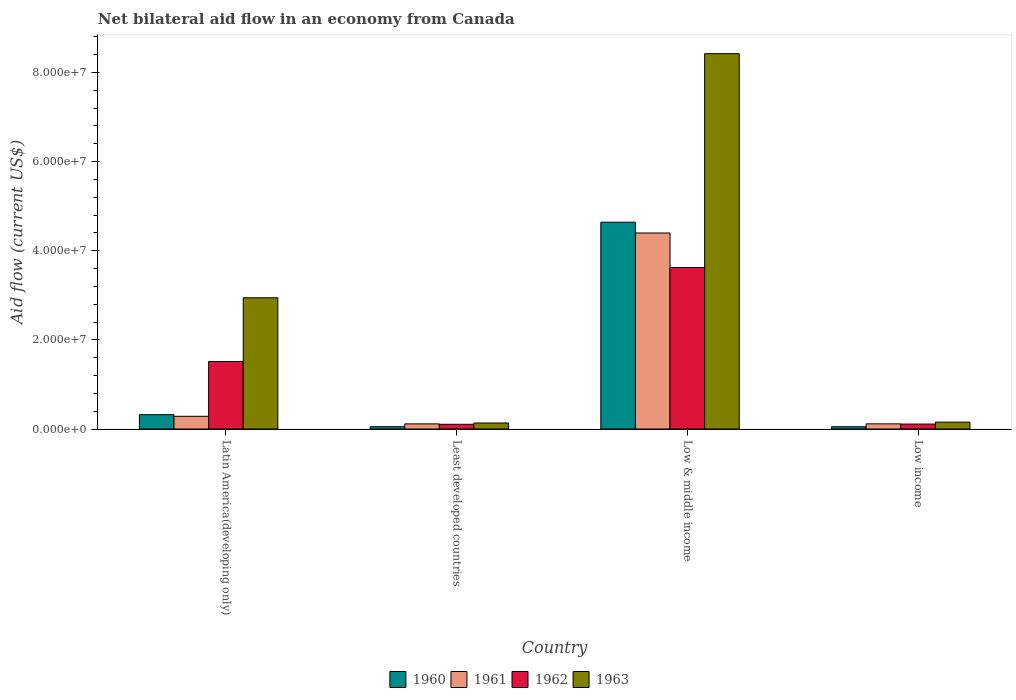How many different coloured bars are there?
Your answer should be very brief. 4. How many groups of bars are there?
Offer a very short reply. 4. Are the number of bars per tick equal to the number of legend labels?
Keep it short and to the point. Yes. How many bars are there on the 1st tick from the left?
Ensure brevity in your answer.  4. What is the label of the 2nd group of bars from the left?
Offer a terse response. Least developed countries. In how many cases, is the number of bars for a given country not equal to the number of legend labels?
Make the answer very short. 0. What is the net bilateral aid flow in 1960 in Least developed countries?
Ensure brevity in your answer.  5.20e+05. Across all countries, what is the maximum net bilateral aid flow in 1963?
Keep it short and to the point. 8.42e+07. Across all countries, what is the minimum net bilateral aid flow in 1963?
Your answer should be compact. 1.35e+06. In which country was the net bilateral aid flow in 1960 maximum?
Make the answer very short. Low & middle income. In which country was the net bilateral aid flow in 1963 minimum?
Your response must be concise. Least developed countries. What is the total net bilateral aid flow in 1960 in the graph?
Make the answer very short. 5.06e+07. What is the difference between the net bilateral aid flow in 1960 in Latin America(developing only) and that in Low & middle income?
Your answer should be very brief. -4.32e+07. What is the difference between the net bilateral aid flow in 1962 in Low income and the net bilateral aid flow in 1961 in Low & middle income?
Your answer should be compact. -4.29e+07. What is the average net bilateral aid flow in 1962 per country?
Provide a succinct answer. 1.34e+07. What is the ratio of the net bilateral aid flow in 1961 in Low & middle income to that in Low income?
Offer a terse response. 37.91. Is the difference between the net bilateral aid flow in 1961 in Latin America(developing only) and Low & middle income greater than the difference between the net bilateral aid flow in 1963 in Latin America(developing only) and Low & middle income?
Offer a terse response. Yes. What is the difference between the highest and the second highest net bilateral aid flow in 1960?
Your response must be concise. 4.32e+07. What is the difference between the highest and the lowest net bilateral aid flow in 1961?
Ensure brevity in your answer.  4.28e+07. In how many countries, is the net bilateral aid flow in 1960 greater than the average net bilateral aid flow in 1960 taken over all countries?
Your answer should be compact. 1. Is the sum of the net bilateral aid flow in 1963 in Least developed countries and Low income greater than the maximum net bilateral aid flow in 1962 across all countries?
Ensure brevity in your answer.  No. What does the 4th bar from the right in Latin America(developing only) represents?
Offer a terse response. 1960. What is the difference between two consecutive major ticks on the Y-axis?
Keep it short and to the point. 2.00e+07. Are the values on the major ticks of Y-axis written in scientific E-notation?
Give a very brief answer. Yes. Does the graph contain any zero values?
Ensure brevity in your answer.  No. Where does the legend appear in the graph?
Keep it short and to the point. Bottom center. How are the legend labels stacked?
Your response must be concise. Horizontal. What is the title of the graph?
Provide a succinct answer. Net bilateral aid flow in an economy from Canada. What is the label or title of the X-axis?
Keep it short and to the point. Country. What is the label or title of the Y-axis?
Your response must be concise. Aid flow (current US$). What is the Aid flow (current US$) of 1960 in Latin America(developing only)?
Offer a very short reply. 3.22e+06. What is the Aid flow (current US$) of 1961 in Latin America(developing only)?
Provide a short and direct response. 2.85e+06. What is the Aid flow (current US$) in 1962 in Latin America(developing only)?
Make the answer very short. 1.52e+07. What is the Aid flow (current US$) in 1963 in Latin America(developing only)?
Offer a very short reply. 2.94e+07. What is the Aid flow (current US$) of 1960 in Least developed countries?
Your answer should be very brief. 5.20e+05. What is the Aid flow (current US$) in 1961 in Least developed countries?
Ensure brevity in your answer.  1.15e+06. What is the Aid flow (current US$) of 1962 in Least developed countries?
Make the answer very short. 1.06e+06. What is the Aid flow (current US$) in 1963 in Least developed countries?
Give a very brief answer. 1.35e+06. What is the Aid flow (current US$) in 1960 in Low & middle income?
Your answer should be very brief. 4.64e+07. What is the Aid flow (current US$) in 1961 in Low & middle income?
Your response must be concise. 4.40e+07. What is the Aid flow (current US$) in 1962 in Low & middle income?
Provide a succinct answer. 3.62e+07. What is the Aid flow (current US$) in 1963 in Low & middle income?
Your answer should be compact. 8.42e+07. What is the Aid flow (current US$) of 1960 in Low income?
Ensure brevity in your answer.  5.10e+05. What is the Aid flow (current US$) in 1961 in Low income?
Keep it short and to the point. 1.16e+06. What is the Aid flow (current US$) in 1962 in Low income?
Keep it short and to the point. 1.11e+06. What is the Aid flow (current US$) in 1963 in Low income?
Ensure brevity in your answer.  1.54e+06. Across all countries, what is the maximum Aid flow (current US$) in 1960?
Give a very brief answer. 4.64e+07. Across all countries, what is the maximum Aid flow (current US$) in 1961?
Your answer should be compact. 4.40e+07. Across all countries, what is the maximum Aid flow (current US$) of 1962?
Offer a terse response. 3.62e+07. Across all countries, what is the maximum Aid flow (current US$) of 1963?
Offer a terse response. 8.42e+07. Across all countries, what is the minimum Aid flow (current US$) of 1960?
Keep it short and to the point. 5.10e+05. Across all countries, what is the minimum Aid flow (current US$) in 1961?
Provide a succinct answer. 1.15e+06. Across all countries, what is the minimum Aid flow (current US$) of 1962?
Keep it short and to the point. 1.06e+06. Across all countries, what is the minimum Aid flow (current US$) in 1963?
Your answer should be compact. 1.35e+06. What is the total Aid flow (current US$) of 1960 in the graph?
Provide a succinct answer. 5.06e+07. What is the total Aid flow (current US$) of 1961 in the graph?
Provide a short and direct response. 4.91e+07. What is the total Aid flow (current US$) of 1962 in the graph?
Offer a very short reply. 5.36e+07. What is the total Aid flow (current US$) of 1963 in the graph?
Provide a short and direct response. 1.17e+08. What is the difference between the Aid flow (current US$) in 1960 in Latin America(developing only) and that in Least developed countries?
Ensure brevity in your answer.  2.70e+06. What is the difference between the Aid flow (current US$) of 1961 in Latin America(developing only) and that in Least developed countries?
Give a very brief answer. 1.70e+06. What is the difference between the Aid flow (current US$) of 1962 in Latin America(developing only) and that in Least developed countries?
Provide a short and direct response. 1.41e+07. What is the difference between the Aid flow (current US$) in 1963 in Latin America(developing only) and that in Least developed countries?
Provide a short and direct response. 2.81e+07. What is the difference between the Aid flow (current US$) in 1960 in Latin America(developing only) and that in Low & middle income?
Make the answer very short. -4.32e+07. What is the difference between the Aid flow (current US$) of 1961 in Latin America(developing only) and that in Low & middle income?
Offer a very short reply. -4.11e+07. What is the difference between the Aid flow (current US$) of 1962 in Latin America(developing only) and that in Low & middle income?
Give a very brief answer. -2.11e+07. What is the difference between the Aid flow (current US$) in 1963 in Latin America(developing only) and that in Low & middle income?
Provide a short and direct response. -5.48e+07. What is the difference between the Aid flow (current US$) of 1960 in Latin America(developing only) and that in Low income?
Make the answer very short. 2.71e+06. What is the difference between the Aid flow (current US$) in 1961 in Latin America(developing only) and that in Low income?
Give a very brief answer. 1.69e+06. What is the difference between the Aid flow (current US$) of 1962 in Latin America(developing only) and that in Low income?
Keep it short and to the point. 1.40e+07. What is the difference between the Aid flow (current US$) of 1963 in Latin America(developing only) and that in Low income?
Offer a terse response. 2.79e+07. What is the difference between the Aid flow (current US$) of 1960 in Least developed countries and that in Low & middle income?
Provide a succinct answer. -4.59e+07. What is the difference between the Aid flow (current US$) of 1961 in Least developed countries and that in Low & middle income?
Your answer should be very brief. -4.28e+07. What is the difference between the Aid flow (current US$) in 1962 in Least developed countries and that in Low & middle income?
Your answer should be compact. -3.52e+07. What is the difference between the Aid flow (current US$) of 1963 in Least developed countries and that in Low & middle income?
Provide a succinct answer. -8.29e+07. What is the difference between the Aid flow (current US$) of 1960 in Least developed countries and that in Low income?
Provide a succinct answer. 10000. What is the difference between the Aid flow (current US$) in 1962 in Least developed countries and that in Low income?
Provide a short and direct response. -5.00e+04. What is the difference between the Aid flow (current US$) of 1963 in Least developed countries and that in Low income?
Make the answer very short. -1.90e+05. What is the difference between the Aid flow (current US$) of 1960 in Low & middle income and that in Low income?
Provide a short and direct response. 4.59e+07. What is the difference between the Aid flow (current US$) in 1961 in Low & middle income and that in Low income?
Ensure brevity in your answer.  4.28e+07. What is the difference between the Aid flow (current US$) of 1962 in Low & middle income and that in Low income?
Give a very brief answer. 3.51e+07. What is the difference between the Aid flow (current US$) in 1963 in Low & middle income and that in Low income?
Your answer should be compact. 8.27e+07. What is the difference between the Aid flow (current US$) of 1960 in Latin America(developing only) and the Aid flow (current US$) of 1961 in Least developed countries?
Offer a terse response. 2.07e+06. What is the difference between the Aid flow (current US$) of 1960 in Latin America(developing only) and the Aid flow (current US$) of 1962 in Least developed countries?
Keep it short and to the point. 2.16e+06. What is the difference between the Aid flow (current US$) in 1960 in Latin America(developing only) and the Aid flow (current US$) in 1963 in Least developed countries?
Provide a short and direct response. 1.87e+06. What is the difference between the Aid flow (current US$) of 1961 in Latin America(developing only) and the Aid flow (current US$) of 1962 in Least developed countries?
Your response must be concise. 1.79e+06. What is the difference between the Aid flow (current US$) of 1961 in Latin America(developing only) and the Aid flow (current US$) of 1963 in Least developed countries?
Make the answer very short. 1.50e+06. What is the difference between the Aid flow (current US$) of 1962 in Latin America(developing only) and the Aid flow (current US$) of 1963 in Least developed countries?
Your answer should be very brief. 1.38e+07. What is the difference between the Aid flow (current US$) of 1960 in Latin America(developing only) and the Aid flow (current US$) of 1961 in Low & middle income?
Provide a succinct answer. -4.08e+07. What is the difference between the Aid flow (current US$) in 1960 in Latin America(developing only) and the Aid flow (current US$) in 1962 in Low & middle income?
Ensure brevity in your answer.  -3.30e+07. What is the difference between the Aid flow (current US$) in 1960 in Latin America(developing only) and the Aid flow (current US$) in 1963 in Low & middle income?
Provide a short and direct response. -8.10e+07. What is the difference between the Aid flow (current US$) in 1961 in Latin America(developing only) and the Aid flow (current US$) in 1962 in Low & middle income?
Provide a succinct answer. -3.34e+07. What is the difference between the Aid flow (current US$) in 1961 in Latin America(developing only) and the Aid flow (current US$) in 1963 in Low & middle income?
Your answer should be compact. -8.14e+07. What is the difference between the Aid flow (current US$) in 1962 in Latin America(developing only) and the Aid flow (current US$) in 1963 in Low & middle income?
Offer a very short reply. -6.91e+07. What is the difference between the Aid flow (current US$) in 1960 in Latin America(developing only) and the Aid flow (current US$) in 1961 in Low income?
Offer a very short reply. 2.06e+06. What is the difference between the Aid flow (current US$) in 1960 in Latin America(developing only) and the Aid flow (current US$) in 1962 in Low income?
Provide a short and direct response. 2.11e+06. What is the difference between the Aid flow (current US$) in 1960 in Latin America(developing only) and the Aid flow (current US$) in 1963 in Low income?
Offer a very short reply. 1.68e+06. What is the difference between the Aid flow (current US$) in 1961 in Latin America(developing only) and the Aid flow (current US$) in 1962 in Low income?
Offer a very short reply. 1.74e+06. What is the difference between the Aid flow (current US$) in 1961 in Latin America(developing only) and the Aid flow (current US$) in 1963 in Low income?
Offer a terse response. 1.31e+06. What is the difference between the Aid flow (current US$) of 1962 in Latin America(developing only) and the Aid flow (current US$) of 1963 in Low income?
Keep it short and to the point. 1.36e+07. What is the difference between the Aid flow (current US$) in 1960 in Least developed countries and the Aid flow (current US$) in 1961 in Low & middle income?
Ensure brevity in your answer.  -4.35e+07. What is the difference between the Aid flow (current US$) in 1960 in Least developed countries and the Aid flow (current US$) in 1962 in Low & middle income?
Provide a succinct answer. -3.57e+07. What is the difference between the Aid flow (current US$) in 1960 in Least developed countries and the Aid flow (current US$) in 1963 in Low & middle income?
Give a very brief answer. -8.37e+07. What is the difference between the Aid flow (current US$) in 1961 in Least developed countries and the Aid flow (current US$) in 1962 in Low & middle income?
Offer a terse response. -3.51e+07. What is the difference between the Aid flow (current US$) in 1961 in Least developed countries and the Aid flow (current US$) in 1963 in Low & middle income?
Offer a terse response. -8.31e+07. What is the difference between the Aid flow (current US$) of 1962 in Least developed countries and the Aid flow (current US$) of 1963 in Low & middle income?
Your response must be concise. -8.32e+07. What is the difference between the Aid flow (current US$) of 1960 in Least developed countries and the Aid flow (current US$) of 1961 in Low income?
Your answer should be compact. -6.40e+05. What is the difference between the Aid flow (current US$) of 1960 in Least developed countries and the Aid flow (current US$) of 1962 in Low income?
Your answer should be very brief. -5.90e+05. What is the difference between the Aid flow (current US$) in 1960 in Least developed countries and the Aid flow (current US$) in 1963 in Low income?
Your response must be concise. -1.02e+06. What is the difference between the Aid flow (current US$) of 1961 in Least developed countries and the Aid flow (current US$) of 1962 in Low income?
Your answer should be compact. 4.00e+04. What is the difference between the Aid flow (current US$) in 1961 in Least developed countries and the Aid flow (current US$) in 1963 in Low income?
Offer a very short reply. -3.90e+05. What is the difference between the Aid flow (current US$) of 1962 in Least developed countries and the Aid flow (current US$) of 1963 in Low income?
Offer a terse response. -4.80e+05. What is the difference between the Aid flow (current US$) of 1960 in Low & middle income and the Aid flow (current US$) of 1961 in Low income?
Provide a succinct answer. 4.52e+07. What is the difference between the Aid flow (current US$) in 1960 in Low & middle income and the Aid flow (current US$) in 1962 in Low income?
Offer a very short reply. 4.53e+07. What is the difference between the Aid flow (current US$) of 1960 in Low & middle income and the Aid flow (current US$) of 1963 in Low income?
Offer a very short reply. 4.49e+07. What is the difference between the Aid flow (current US$) in 1961 in Low & middle income and the Aid flow (current US$) in 1962 in Low income?
Offer a very short reply. 4.29e+07. What is the difference between the Aid flow (current US$) of 1961 in Low & middle income and the Aid flow (current US$) of 1963 in Low income?
Ensure brevity in your answer.  4.24e+07. What is the difference between the Aid flow (current US$) of 1962 in Low & middle income and the Aid flow (current US$) of 1963 in Low income?
Give a very brief answer. 3.47e+07. What is the average Aid flow (current US$) in 1960 per country?
Make the answer very short. 1.27e+07. What is the average Aid flow (current US$) in 1961 per country?
Make the answer very short. 1.23e+07. What is the average Aid flow (current US$) in 1962 per country?
Your answer should be very brief. 1.34e+07. What is the average Aid flow (current US$) in 1963 per country?
Give a very brief answer. 2.91e+07. What is the difference between the Aid flow (current US$) of 1960 and Aid flow (current US$) of 1961 in Latin America(developing only)?
Your answer should be compact. 3.70e+05. What is the difference between the Aid flow (current US$) in 1960 and Aid flow (current US$) in 1962 in Latin America(developing only)?
Offer a very short reply. -1.19e+07. What is the difference between the Aid flow (current US$) in 1960 and Aid flow (current US$) in 1963 in Latin America(developing only)?
Your answer should be compact. -2.62e+07. What is the difference between the Aid flow (current US$) in 1961 and Aid flow (current US$) in 1962 in Latin America(developing only)?
Your answer should be very brief. -1.23e+07. What is the difference between the Aid flow (current US$) in 1961 and Aid flow (current US$) in 1963 in Latin America(developing only)?
Your response must be concise. -2.66e+07. What is the difference between the Aid flow (current US$) in 1962 and Aid flow (current US$) in 1963 in Latin America(developing only)?
Give a very brief answer. -1.43e+07. What is the difference between the Aid flow (current US$) in 1960 and Aid flow (current US$) in 1961 in Least developed countries?
Your answer should be compact. -6.30e+05. What is the difference between the Aid flow (current US$) of 1960 and Aid flow (current US$) of 1962 in Least developed countries?
Keep it short and to the point. -5.40e+05. What is the difference between the Aid flow (current US$) of 1960 and Aid flow (current US$) of 1963 in Least developed countries?
Your answer should be very brief. -8.30e+05. What is the difference between the Aid flow (current US$) of 1962 and Aid flow (current US$) of 1963 in Least developed countries?
Make the answer very short. -2.90e+05. What is the difference between the Aid flow (current US$) in 1960 and Aid flow (current US$) in 1961 in Low & middle income?
Provide a succinct answer. 2.42e+06. What is the difference between the Aid flow (current US$) in 1960 and Aid flow (current US$) in 1962 in Low & middle income?
Give a very brief answer. 1.02e+07. What is the difference between the Aid flow (current US$) in 1960 and Aid flow (current US$) in 1963 in Low & middle income?
Offer a very short reply. -3.78e+07. What is the difference between the Aid flow (current US$) in 1961 and Aid flow (current US$) in 1962 in Low & middle income?
Offer a very short reply. 7.74e+06. What is the difference between the Aid flow (current US$) in 1961 and Aid flow (current US$) in 1963 in Low & middle income?
Your answer should be compact. -4.02e+07. What is the difference between the Aid flow (current US$) of 1962 and Aid flow (current US$) of 1963 in Low & middle income?
Your response must be concise. -4.80e+07. What is the difference between the Aid flow (current US$) of 1960 and Aid flow (current US$) of 1961 in Low income?
Give a very brief answer. -6.50e+05. What is the difference between the Aid flow (current US$) in 1960 and Aid flow (current US$) in 1962 in Low income?
Offer a very short reply. -6.00e+05. What is the difference between the Aid flow (current US$) in 1960 and Aid flow (current US$) in 1963 in Low income?
Your answer should be very brief. -1.03e+06. What is the difference between the Aid flow (current US$) in 1961 and Aid flow (current US$) in 1962 in Low income?
Your answer should be compact. 5.00e+04. What is the difference between the Aid flow (current US$) of 1961 and Aid flow (current US$) of 1963 in Low income?
Give a very brief answer. -3.80e+05. What is the difference between the Aid flow (current US$) in 1962 and Aid flow (current US$) in 1963 in Low income?
Your response must be concise. -4.30e+05. What is the ratio of the Aid flow (current US$) of 1960 in Latin America(developing only) to that in Least developed countries?
Provide a short and direct response. 6.19. What is the ratio of the Aid flow (current US$) of 1961 in Latin America(developing only) to that in Least developed countries?
Ensure brevity in your answer.  2.48. What is the ratio of the Aid flow (current US$) in 1962 in Latin America(developing only) to that in Least developed countries?
Your response must be concise. 14.29. What is the ratio of the Aid flow (current US$) in 1963 in Latin America(developing only) to that in Least developed countries?
Make the answer very short. 21.81. What is the ratio of the Aid flow (current US$) of 1960 in Latin America(developing only) to that in Low & middle income?
Your response must be concise. 0.07. What is the ratio of the Aid flow (current US$) in 1961 in Latin America(developing only) to that in Low & middle income?
Make the answer very short. 0.06. What is the ratio of the Aid flow (current US$) of 1962 in Latin America(developing only) to that in Low & middle income?
Offer a terse response. 0.42. What is the ratio of the Aid flow (current US$) in 1963 in Latin America(developing only) to that in Low & middle income?
Your answer should be compact. 0.35. What is the ratio of the Aid flow (current US$) of 1960 in Latin America(developing only) to that in Low income?
Provide a succinct answer. 6.31. What is the ratio of the Aid flow (current US$) of 1961 in Latin America(developing only) to that in Low income?
Provide a short and direct response. 2.46. What is the ratio of the Aid flow (current US$) in 1962 in Latin America(developing only) to that in Low income?
Provide a succinct answer. 13.65. What is the ratio of the Aid flow (current US$) in 1963 in Latin America(developing only) to that in Low income?
Offer a very short reply. 19.12. What is the ratio of the Aid flow (current US$) in 1960 in Least developed countries to that in Low & middle income?
Give a very brief answer. 0.01. What is the ratio of the Aid flow (current US$) in 1961 in Least developed countries to that in Low & middle income?
Your answer should be compact. 0.03. What is the ratio of the Aid flow (current US$) in 1962 in Least developed countries to that in Low & middle income?
Your response must be concise. 0.03. What is the ratio of the Aid flow (current US$) of 1963 in Least developed countries to that in Low & middle income?
Offer a very short reply. 0.02. What is the ratio of the Aid flow (current US$) in 1960 in Least developed countries to that in Low income?
Keep it short and to the point. 1.02. What is the ratio of the Aid flow (current US$) of 1962 in Least developed countries to that in Low income?
Offer a very short reply. 0.95. What is the ratio of the Aid flow (current US$) of 1963 in Least developed countries to that in Low income?
Keep it short and to the point. 0.88. What is the ratio of the Aid flow (current US$) of 1960 in Low & middle income to that in Low income?
Your answer should be compact. 90.98. What is the ratio of the Aid flow (current US$) of 1961 in Low & middle income to that in Low income?
Provide a short and direct response. 37.91. What is the ratio of the Aid flow (current US$) of 1962 in Low & middle income to that in Low income?
Ensure brevity in your answer.  32.65. What is the ratio of the Aid flow (current US$) of 1963 in Low & middle income to that in Low income?
Ensure brevity in your answer.  54.69. What is the difference between the highest and the second highest Aid flow (current US$) of 1960?
Provide a short and direct response. 4.32e+07. What is the difference between the highest and the second highest Aid flow (current US$) of 1961?
Keep it short and to the point. 4.11e+07. What is the difference between the highest and the second highest Aid flow (current US$) of 1962?
Ensure brevity in your answer.  2.11e+07. What is the difference between the highest and the second highest Aid flow (current US$) in 1963?
Provide a short and direct response. 5.48e+07. What is the difference between the highest and the lowest Aid flow (current US$) of 1960?
Provide a short and direct response. 4.59e+07. What is the difference between the highest and the lowest Aid flow (current US$) of 1961?
Ensure brevity in your answer.  4.28e+07. What is the difference between the highest and the lowest Aid flow (current US$) of 1962?
Offer a very short reply. 3.52e+07. What is the difference between the highest and the lowest Aid flow (current US$) in 1963?
Offer a very short reply. 8.29e+07. 